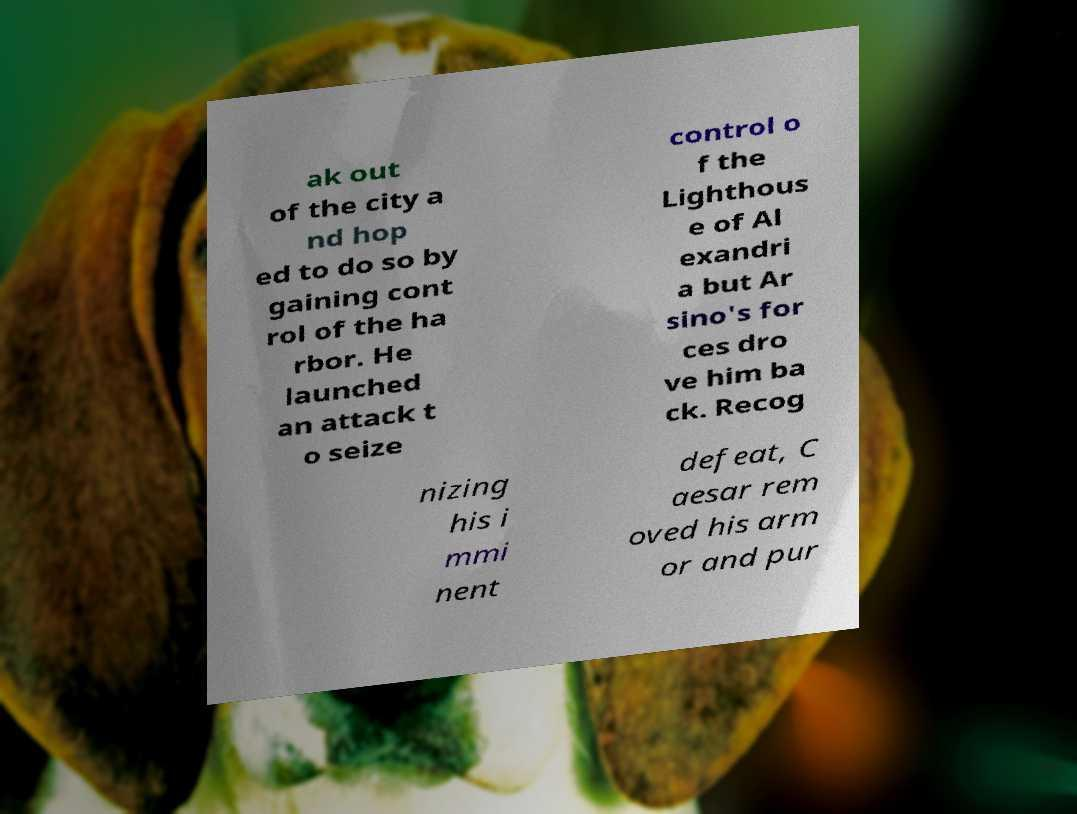Could you assist in decoding the text presented in this image and type it out clearly? ak out of the city a nd hop ed to do so by gaining cont rol of the ha rbor. He launched an attack t o seize control o f the Lighthous e of Al exandri a but Ar sino's for ces dro ve him ba ck. Recog nizing his i mmi nent defeat, C aesar rem oved his arm or and pur 